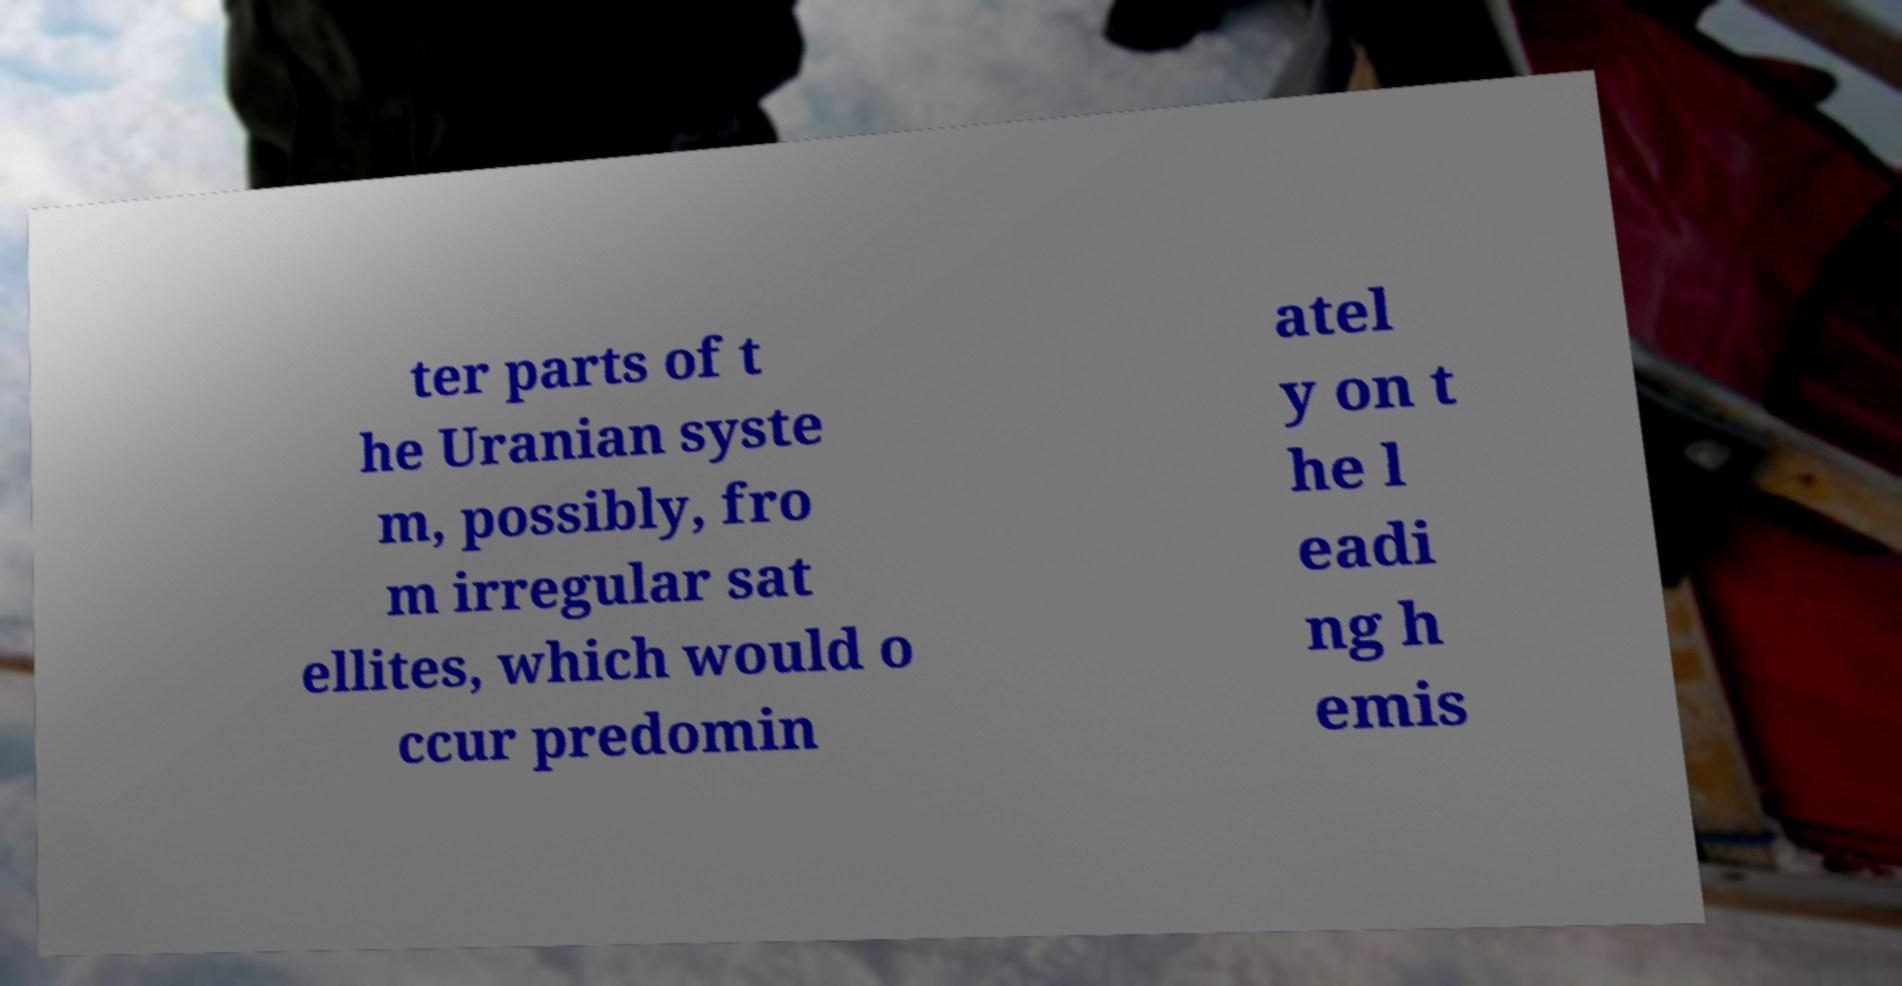Can you read and provide the text displayed in the image?This photo seems to have some interesting text. Can you extract and type it out for me? ter parts of t he Uranian syste m, possibly, fro m irregular sat ellites, which would o ccur predomin atel y on t he l eadi ng h emis 